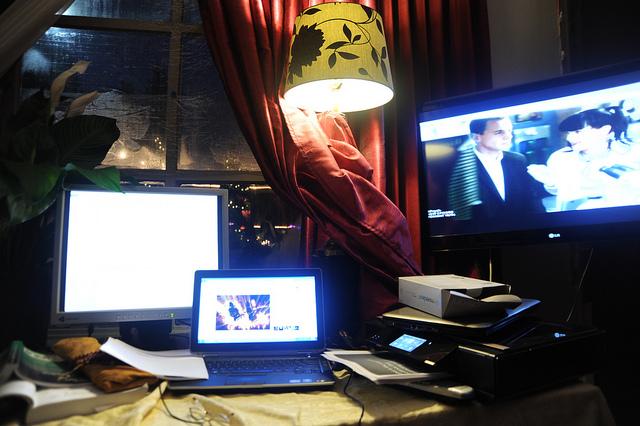What color are the curtains?
Keep it brief. Red. What is the design on the lampshade?
Answer briefly. Flowers. How many computers are in the photo?
Quick response, please. 2. 